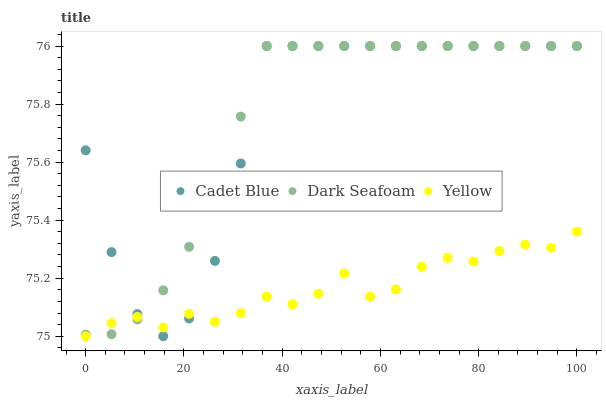Does Yellow have the minimum area under the curve?
Answer yes or no. Yes. Does Dark Seafoam have the maximum area under the curve?
Answer yes or no. Yes. Does Cadet Blue have the minimum area under the curve?
Answer yes or no. No. Does Cadet Blue have the maximum area under the curve?
Answer yes or no. No. Is Dark Seafoam the smoothest?
Answer yes or no. Yes. Is Cadet Blue the roughest?
Answer yes or no. Yes. Is Yellow the smoothest?
Answer yes or no. No. Is Yellow the roughest?
Answer yes or no. No. Does Yellow have the lowest value?
Answer yes or no. Yes. Does Cadet Blue have the lowest value?
Answer yes or no. No. Does Cadet Blue have the highest value?
Answer yes or no. Yes. Does Yellow have the highest value?
Answer yes or no. No. Does Cadet Blue intersect Dark Seafoam?
Answer yes or no. Yes. Is Cadet Blue less than Dark Seafoam?
Answer yes or no. No. Is Cadet Blue greater than Dark Seafoam?
Answer yes or no. No. 